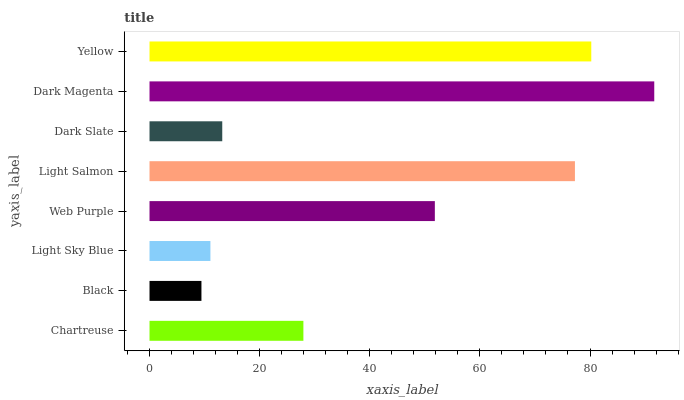Is Black the minimum?
Answer yes or no. Yes. Is Dark Magenta the maximum?
Answer yes or no. Yes. Is Light Sky Blue the minimum?
Answer yes or no. No. Is Light Sky Blue the maximum?
Answer yes or no. No. Is Light Sky Blue greater than Black?
Answer yes or no. Yes. Is Black less than Light Sky Blue?
Answer yes or no. Yes. Is Black greater than Light Sky Blue?
Answer yes or no. No. Is Light Sky Blue less than Black?
Answer yes or no. No. Is Web Purple the high median?
Answer yes or no. Yes. Is Chartreuse the low median?
Answer yes or no. Yes. Is Chartreuse the high median?
Answer yes or no. No. Is Black the low median?
Answer yes or no. No. 